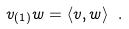<formula> <loc_0><loc_0><loc_500><loc_500>v _ { ( 1 ) } w = \langle v , w \rangle \ .</formula> 